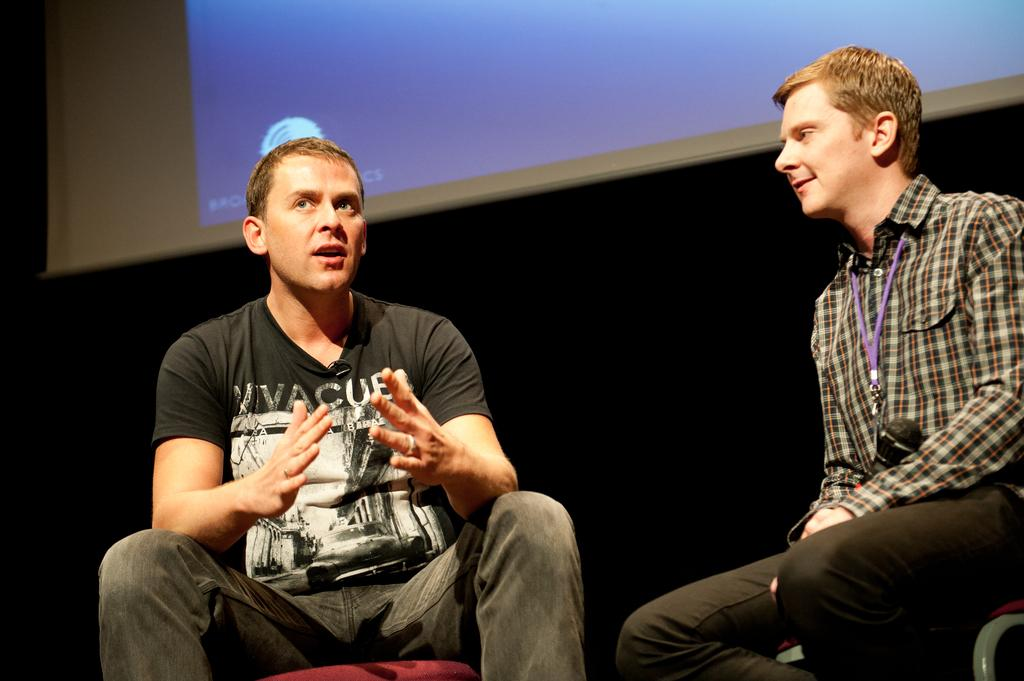How many people are in the image? There are two persons in the image. What are the persons doing in the image? The persons are sitting on chairs. What can be seen in the background of the image? The background of the image is dark. What is the main feature at the top of the image? There is a projected screen at the top of the image. What type of behavior is the cook exhibiting in the image? There is no cook present in the image, so it is not possible to determine their behavior. 